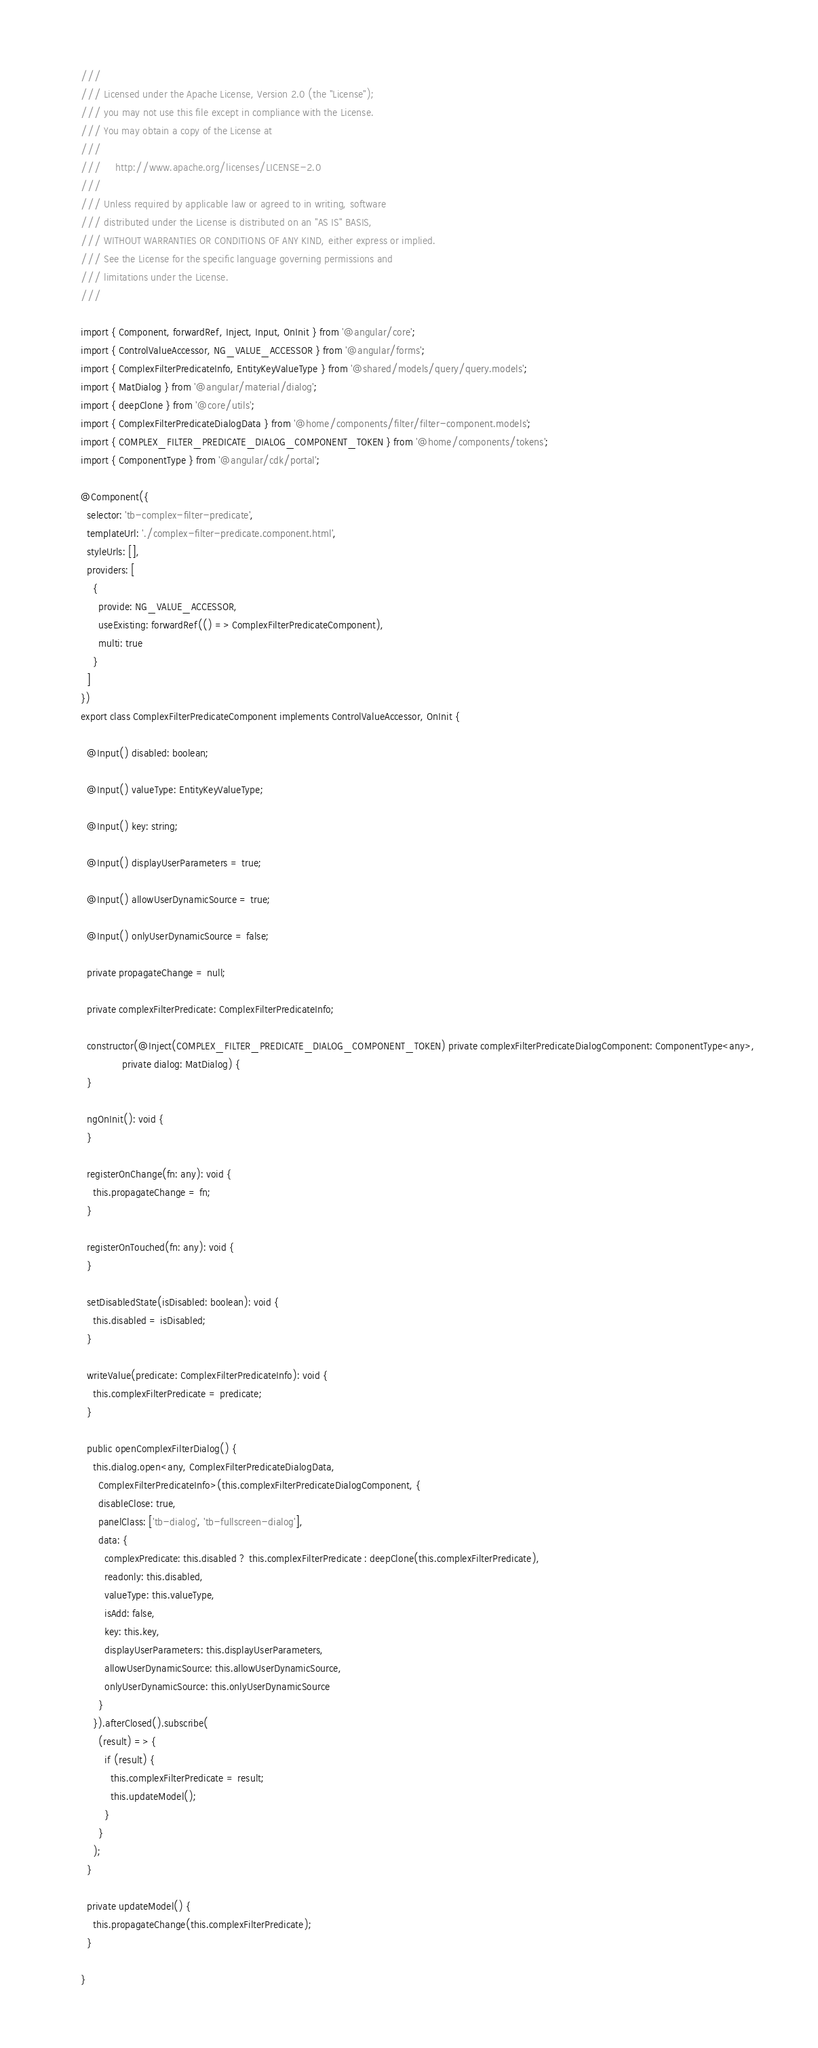Convert code to text. <code><loc_0><loc_0><loc_500><loc_500><_TypeScript_>///
/// Licensed under the Apache License, Version 2.0 (the "License");
/// you may not use this file except in compliance with the License.
/// You may obtain a copy of the License at
///
///     http://www.apache.org/licenses/LICENSE-2.0
///
/// Unless required by applicable law or agreed to in writing, software
/// distributed under the License is distributed on an "AS IS" BASIS,
/// WITHOUT WARRANTIES OR CONDITIONS OF ANY KIND, either express or implied.
/// See the License for the specific language governing permissions and
/// limitations under the License.
///

import { Component, forwardRef, Inject, Input, OnInit } from '@angular/core';
import { ControlValueAccessor, NG_VALUE_ACCESSOR } from '@angular/forms';
import { ComplexFilterPredicateInfo, EntityKeyValueType } from '@shared/models/query/query.models';
import { MatDialog } from '@angular/material/dialog';
import { deepClone } from '@core/utils';
import { ComplexFilterPredicateDialogData } from '@home/components/filter/filter-component.models';
import { COMPLEX_FILTER_PREDICATE_DIALOG_COMPONENT_TOKEN } from '@home/components/tokens';
import { ComponentType } from '@angular/cdk/portal';

@Component({
  selector: 'tb-complex-filter-predicate',
  templateUrl: './complex-filter-predicate.component.html',
  styleUrls: [],
  providers: [
    {
      provide: NG_VALUE_ACCESSOR,
      useExisting: forwardRef(() => ComplexFilterPredicateComponent),
      multi: true
    }
  ]
})
export class ComplexFilterPredicateComponent implements ControlValueAccessor, OnInit {

  @Input() disabled: boolean;

  @Input() valueType: EntityKeyValueType;

  @Input() key: string;

  @Input() displayUserParameters = true;

  @Input() allowUserDynamicSource = true;

  @Input() onlyUserDynamicSource = false;

  private propagateChange = null;

  private complexFilterPredicate: ComplexFilterPredicateInfo;

  constructor(@Inject(COMPLEX_FILTER_PREDICATE_DIALOG_COMPONENT_TOKEN) private complexFilterPredicateDialogComponent: ComponentType<any>,
              private dialog: MatDialog) {
  }

  ngOnInit(): void {
  }

  registerOnChange(fn: any): void {
    this.propagateChange = fn;
  }

  registerOnTouched(fn: any): void {
  }

  setDisabledState(isDisabled: boolean): void {
    this.disabled = isDisabled;
  }

  writeValue(predicate: ComplexFilterPredicateInfo): void {
    this.complexFilterPredicate = predicate;
  }

  public openComplexFilterDialog() {
    this.dialog.open<any, ComplexFilterPredicateDialogData,
      ComplexFilterPredicateInfo>(this.complexFilterPredicateDialogComponent, {
      disableClose: true,
      panelClass: ['tb-dialog', 'tb-fullscreen-dialog'],
      data: {
        complexPredicate: this.disabled ? this.complexFilterPredicate : deepClone(this.complexFilterPredicate),
        readonly: this.disabled,
        valueType: this.valueType,
        isAdd: false,
        key: this.key,
        displayUserParameters: this.displayUserParameters,
        allowUserDynamicSource: this.allowUserDynamicSource,
        onlyUserDynamicSource: this.onlyUserDynamicSource
      }
    }).afterClosed().subscribe(
      (result) => {
        if (result) {
          this.complexFilterPredicate = result;
          this.updateModel();
        }
      }
    );
  }

  private updateModel() {
    this.propagateChange(this.complexFilterPredicate);
  }

}
</code> 